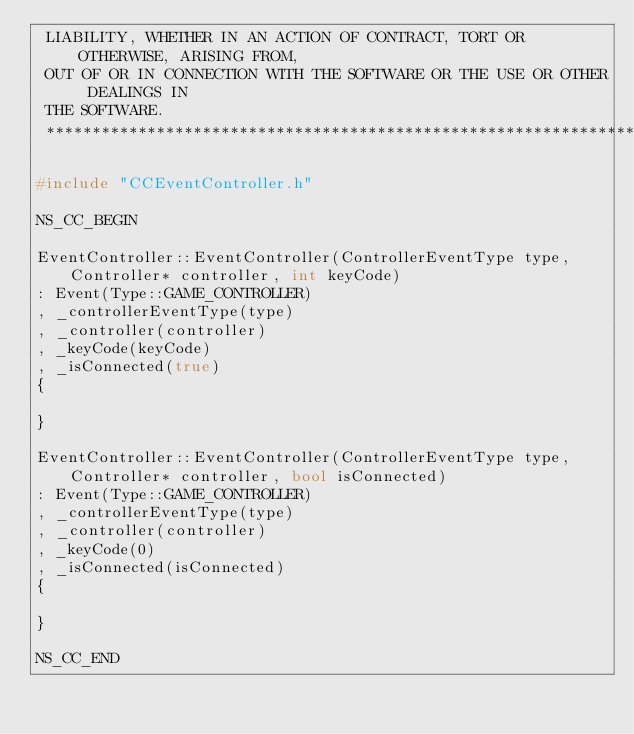<code> <loc_0><loc_0><loc_500><loc_500><_C++_> LIABILITY, WHETHER IN AN ACTION OF CONTRACT, TORT OR OTHERWISE, ARISING FROM,
 OUT OF OR IN CONNECTION WITH THE SOFTWARE OR THE USE OR OTHER DEALINGS IN
 THE SOFTWARE.
 ****************************************************************************/

#include "CCEventController.h"

NS_CC_BEGIN

EventController::EventController(ControllerEventType type, Controller* controller, int keyCode)
: Event(Type::GAME_CONTROLLER)
, _controllerEventType(type)
, _controller(controller)
, _keyCode(keyCode)
, _isConnected(true)
{
    
}

EventController::EventController(ControllerEventType type, Controller* controller, bool isConnected)
: Event(Type::GAME_CONTROLLER)
, _controllerEventType(type)
, _controller(controller)
, _keyCode(0)
, _isConnected(isConnected)
{
    
}

NS_CC_END
</code> 